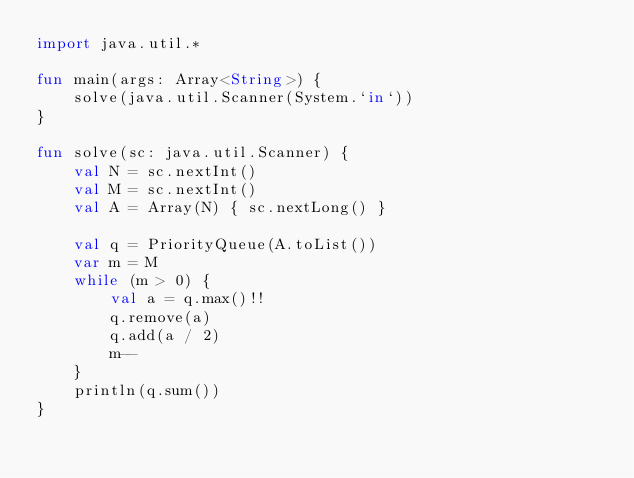Convert code to text. <code><loc_0><loc_0><loc_500><loc_500><_Kotlin_>import java.util.*

fun main(args: Array<String>) {
    solve(java.util.Scanner(System.`in`))
}

fun solve(sc: java.util.Scanner) {
    val N = sc.nextInt()
    val M = sc.nextInt()
    val A = Array(N) { sc.nextLong() }

    val q = PriorityQueue(A.toList())
    var m = M
    while (m > 0) {
        val a = q.max()!!
        q.remove(a)
        q.add(a / 2)
        m--
    }
    println(q.sum())
}
</code> 